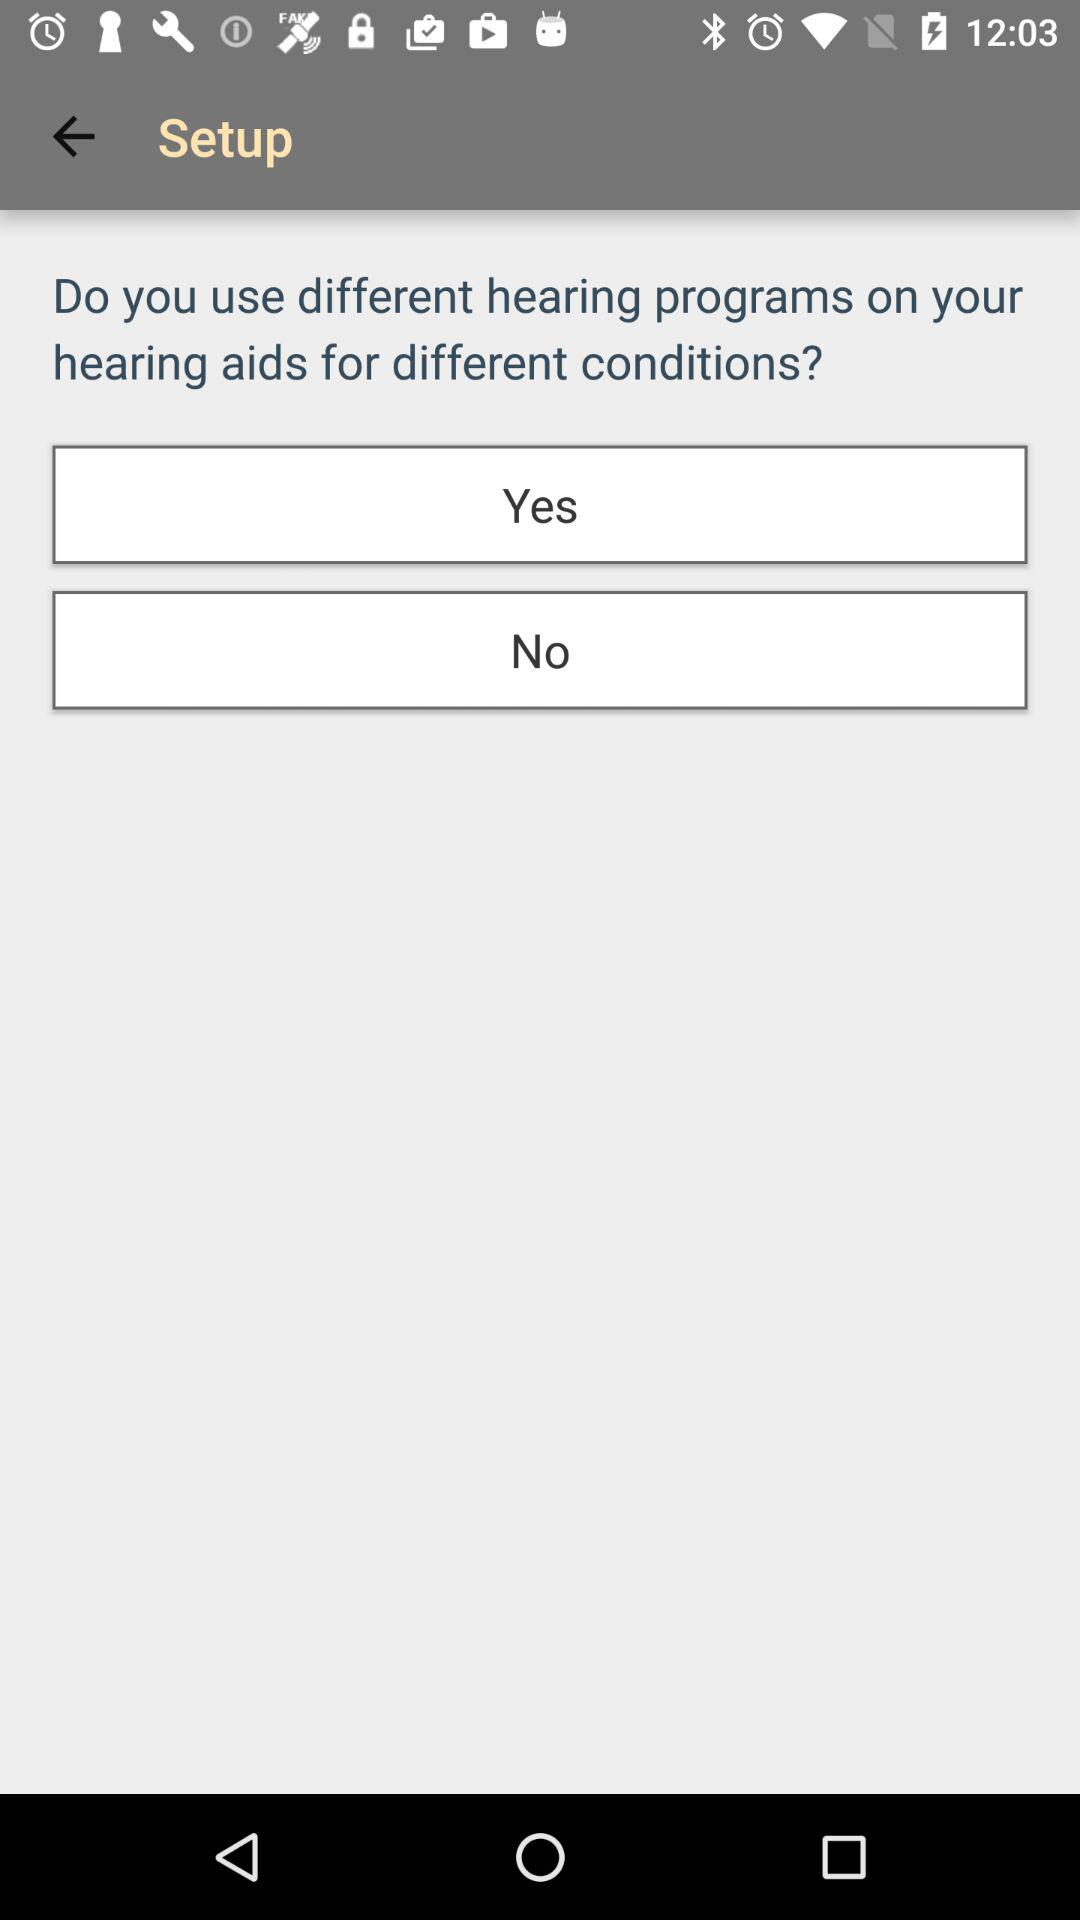How many options are available for the user to respond to the question?
Answer the question using a single word or phrase. 2 